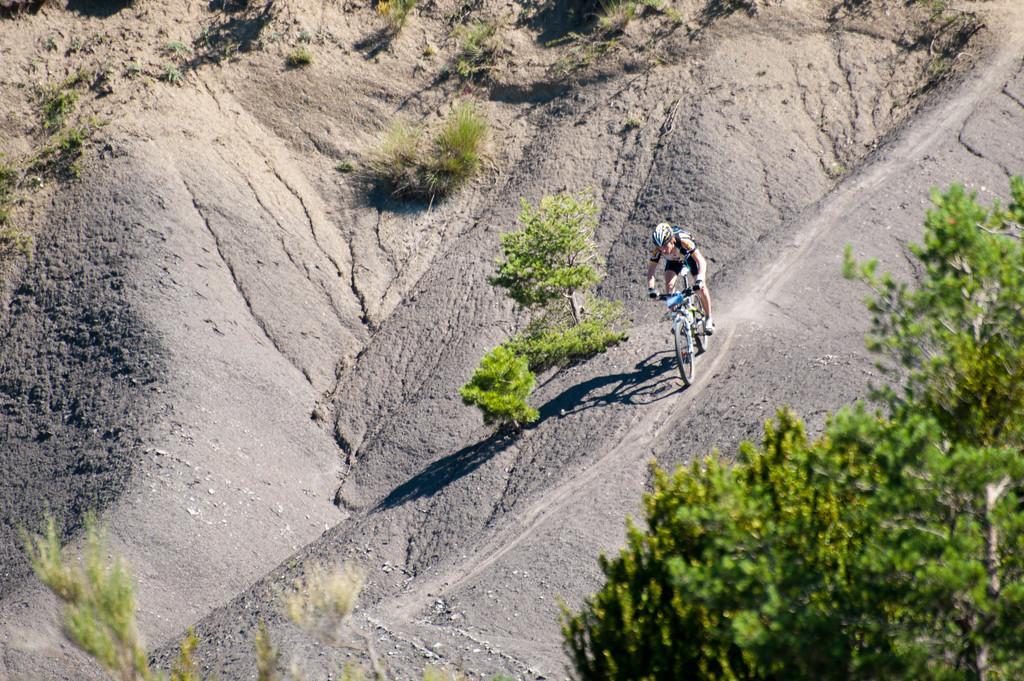Describe this image in one or two sentences. In this image there is a person cycling on the path and there are some trees and plants on the surface. 